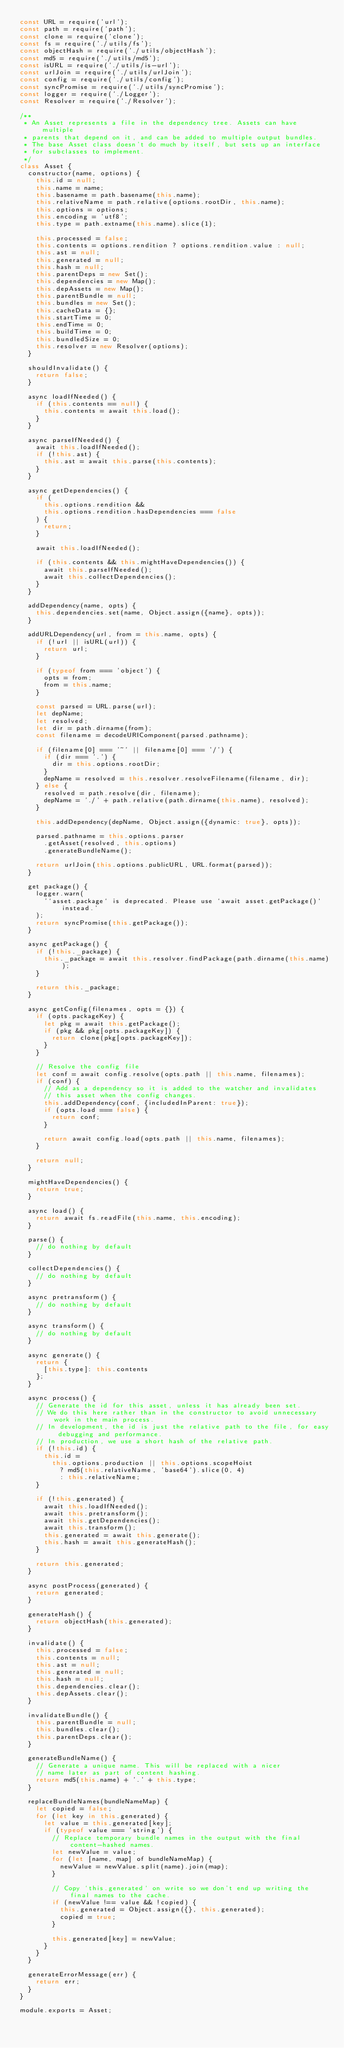Convert code to text. <code><loc_0><loc_0><loc_500><loc_500><_JavaScript_>const URL = require('url');
const path = require('path');
const clone = require('clone');
const fs = require('./utils/fs');
const objectHash = require('./utils/objectHash');
const md5 = require('./utils/md5');
const isURL = require('./utils/is-url');
const urlJoin = require('./utils/urlJoin');
const config = require('./utils/config');
const syncPromise = require('./utils/syncPromise');
const logger = require('./Logger');
const Resolver = require('./Resolver');

/**
 * An Asset represents a file in the dependency tree. Assets can have multiple
 * parents that depend on it, and can be added to multiple output bundles.
 * The base Asset class doesn't do much by itself, but sets up an interface
 * for subclasses to implement.
 */
class Asset {
  constructor(name, options) {
    this.id = null;
    this.name = name;
    this.basename = path.basename(this.name);
    this.relativeName = path.relative(options.rootDir, this.name);
    this.options = options;
    this.encoding = 'utf8';
    this.type = path.extname(this.name).slice(1);

    this.processed = false;
    this.contents = options.rendition ? options.rendition.value : null;
    this.ast = null;
    this.generated = null;
    this.hash = null;
    this.parentDeps = new Set();
    this.dependencies = new Map();
    this.depAssets = new Map();
    this.parentBundle = null;
    this.bundles = new Set();
    this.cacheData = {};
    this.startTime = 0;
    this.endTime = 0;
    this.buildTime = 0;
    this.bundledSize = 0;
    this.resolver = new Resolver(options);
  }

  shouldInvalidate() {
    return false;
  }

  async loadIfNeeded() {
    if (this.contents == null) {
      this.contents = await this.load();
    }
  }

  async parseIfNeeded() {
    await this.loadIfNeeded();
    if (!this.ast) {
      this.ast = await this.parse(this.contents);
    }
  }

  async getDependencies() {
    if (
      this.options.rendition &&
      this.options.rendition.hasDependencies === false
    ) {
      return;
    }

    await this.loadIfNeeded();

    if (this.contents && this.mightHaveDependencies()) {
      await this.parseIfNeeded();
      await this.collectDependencies();
    }
  }

  addDependency(name, opts) {
    this.dependencies.set(name, Object.assign({name}, opts));
  }

  addURLDependency(url, from = this.name, opts) {
    if (!url || isURL(url)) {
      return url;
    }

    if (typeof from === 'object') {
      opts = from;
      from = this.name;
    }

    const parsed = URL.parse(url);
    let depName;
    let resolved;
    let dir = path.dirname(from);
    const filename = decodeURIComponent(parsed.pathname);

    if (filename[0] === '~' || filename[0] === '/') {
      if (dir === '.') {
        dir = this.options.rootDir;
      }
      depName = resolved = this.resolver.resolveFilename(filename, dir);
    } else {
      resolved = path.resolve(dir, filename);
      depName = './' + path.relative(path.dirname(this.name), resolved);
    }

    this.addDependency(depName, Object.assign({dynamic: true}, opts));

    parsed.pathname = this.options.parser
      .getAsset(resolved, this.options)
      .generateBundleName();

    return urlJoin(this.options.publicURL, URL.format(parsed));
  }

  get package() {
    logger.warn(
      '`asset.package` is deprecated. Please use `await asset.getPackage()` instead.'
    );
    return syncPromise(this.getPackage());
  }

  async getPackage() {
    if (!this._package) {
      this._package = await this.resolver.findPackage(path.dirname(this.name));
    }

    return this._package;
  }

  async getConfig(filenames, opts = {}) {
    if (opts.packageKey) {
      let pkg = await this.getPackage();
      if (pkg && pkg[opts.packageKey]) {
        return clone(pkg[opts.packageKey]);
      }
    }

    // Resolve the config file
    let conf = await config.resolve(opts.path || this.name, filenames);
    if (conf) {
      // Add as a dependency so it is added to the watcher and invalidates
      // this asset when the config changes.
      this.addDependency(conf, {includedInParent: true});
      if (opts.load === false) {
        return conf;
      }

      return await config.load(opts.path || this.name, filenames);
    }

    return null;
  }

  mightHaveDependencies() {
    return true;
  }

  async load() {
    return await fs.readFile(this.name, this.encoding);
  }

  parse() {
    // do nothing by default
  }

  collectDependencies() {
    // do nothing by default
  }

  async pretransform() {
    // do nothing by default
  }

  async transform() {
    // do nothing by default
  }

  async generate() {
    return {
      [this.type]: this.contents
    };
  }

  async process() {
    // Generate the id for this asset, unless it has already been set.
    // We do this here rather than in the constructor to avoid unnecessary work in the main process.
    // In development, the id is just the relative path to the file, for easy debugging and performance.
    // In production, we use a short hash of the relative path.
    if (!this.id) {
      this.id =
        this.options.production || this.options.scopeHoist
          ? md5(this.relativeName, 'base64').slice(0, 4)
          : this.relativeName;
    }

    if (!this.generated) {
      await this.loadIfNeeded();
      await this.pretransform();
      await this.getDependencies();
      await this.transform();
      this.generated = await this.generate();
      this.hash = await this.generateHash();
    }

    return this.generated;
  }

  async postProcess(generated) {
    return generated;
  }

  generateHash() {
    return objectHash(this.generated);
  }

  invalidate() {
    this.processed = false;
    this.contents = null;
    this.ast = null;
    this.generated = null;
    this.hash = null;
    this.dependencies.clear();
    this.depAssets.clear();
  }

  invalidateBundle() {
    this.parentBundle = null;
    this.bundles.clear();
    this.parentDeps.clear();
  }

  generateBundleName() {
    // Generate a unique name. This will be replaced with a nicer
    // name later as part of content hashing.
    return md5(this.name) + '.' + this.type;
  }

  replaceBundleNames(bundleNameMap) {
    let copied = false;
    for (let key in this.generated) {
      let value = this.generated[key];
      if (typeof value === 'string') {
        // Replace temporary bundle names in the output with the final content-hashed names.
        let newValue = value;
        for (let [name, map] of bundleNameMap) {
          newValue = newValue.split(name).join(map);
        }

        // Copy `this.generated` on write so we don't end up writing the final names to the cache.
        if (newValue !== value && !copied) {
          this.generated = Object.assign({}, this.generated);
          copied = true;
        }

        this.generated[key] = newValue;
      }
    }
  }

  generateErrorMessage(err) {
    return err;
  }
}

module.exports = Asset;
</code> 